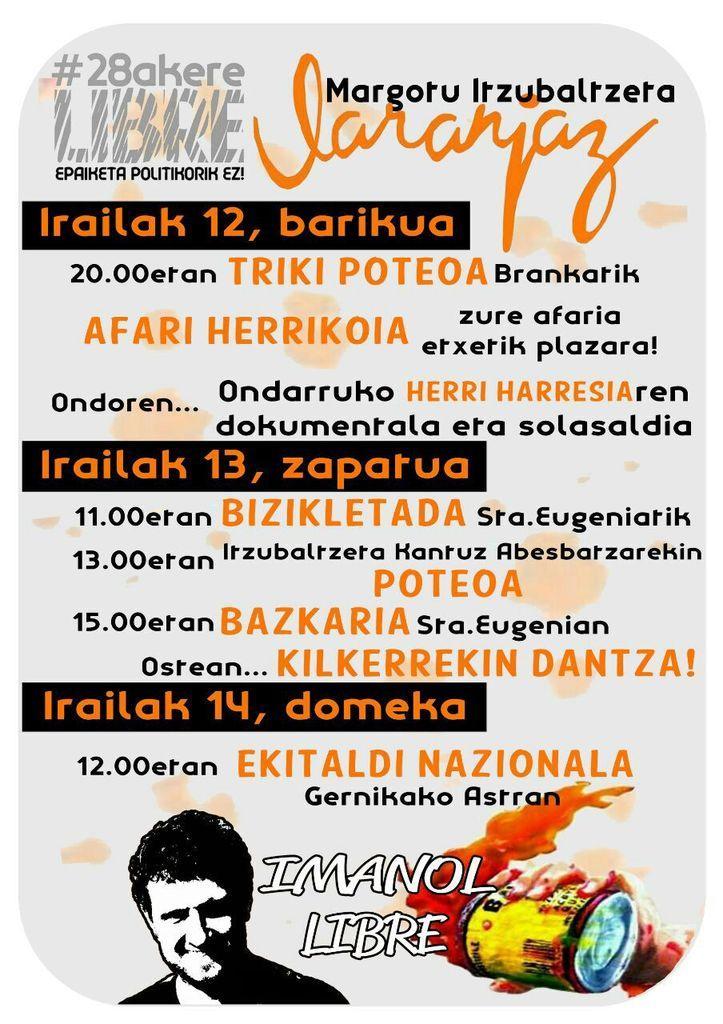Please provide a concise description of this image. In this image there is a poster of some images and some text. 